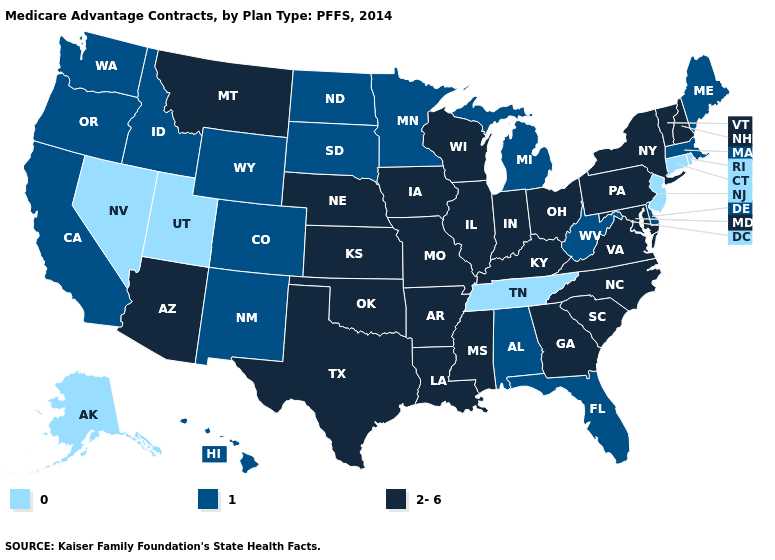Name the states that have a value in the range 1?
Write a very short answer. Alabama, California, Colorado, Delaware, Florida, Hawaii, Idaho, Massachusetts, Maine, Michigan, Minnesota, North Dakota, New Mexico, Oregon, South Dakota, Washington, West Virginia, Wyoming. What is the highest value in the MidWest ?
Give a very brief answer. 2-6. What is the highest value in states that border Illinois?
Short answer required. 2-6. What is the lowest value in the MidWest?
Keep it brief. 1. Does the map have missing data?
Answer briefly. No. Does Oregon have the same value as Idaho?
Keep it brief. Yes. Is the legend a continuous bar?
Be succinct. No. What is the value of New Jersey?
Answer briefly. 0. Does Massachusetts have the same value as Maryland?
Write a very short answer. No. What is the value of Alabama?
Answer briefly. 1. Name the states that have a value in the range 2-6?
Keep it brief. Arkansas, Arizona, Georgia, Iowa, Illinois, Indiana, Kansas, Kentucky, Louisiana, Maryland, Missouri, Mississippi, Montana, North Carolina, Nebraska, New Hampshire, New York, Ohio, Oklahoma, Pennsylvania, South Carolina, Texas, Virginia, Vermont, Wisconsin. Name the states that have a value in the range 2-6?
Keep it brief. Arkansas, Arizona, Georgia, Iowa, Illinois, Indiana, Kansas, Kentucky, Louisiana, Maryland, Missouri, Mississippi, Montana, North Carolina, Nebraska, New Hampshire, New York, Ohio, Oklahoma, Pennsylvania, South Carolina, Texas, Virginia, Vermont, Wisconsin. Is the legend a continuous bar?
Concise answer only. No. Name the states that have a value in the range 0?
Be succinct. Alaska, Connecticut, New Jersey, Nevada, Rhode Island, Tennessee, Utah. What is the highest value in the USA?
Be succinct. 2-6. 